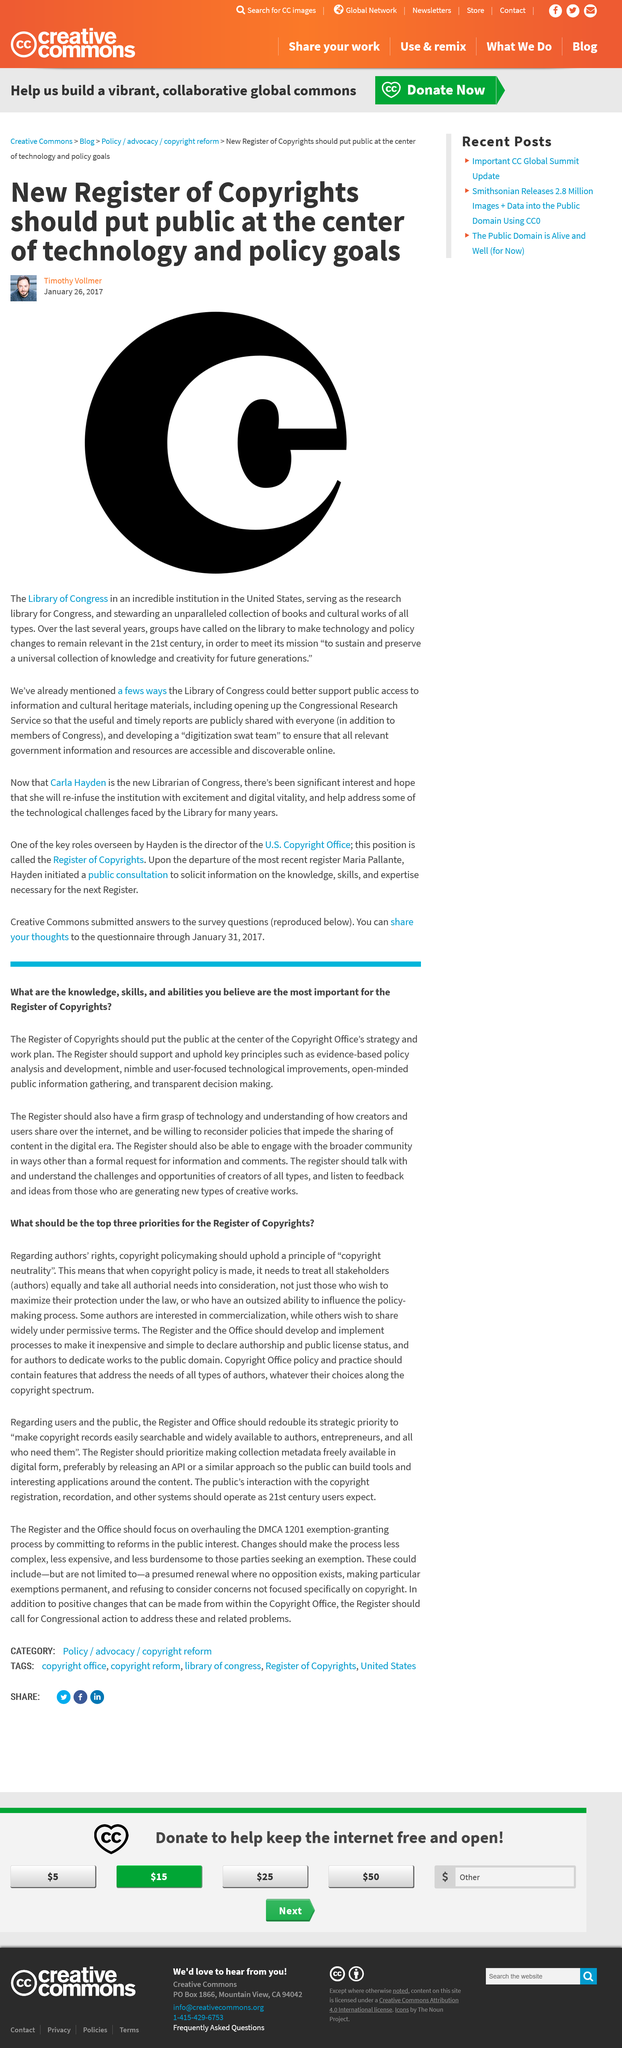Identify some key points in this picture. There is a Copyright Office that exists. The Library of Congress serves as the primary research library for Congress. The Library of Congress is being asked to make technological changes. Transparent decision-making is a crucial aspect of the Copyright Office's strategic plan and work agenda. Yes, there is a Register of Copyrights. 